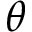Convert formula to latex. <formula><loc_0><loc_0><loc_500><loc_500>\theta</formula> 